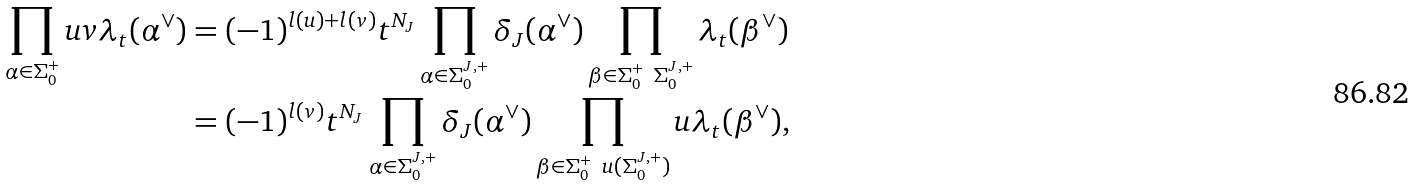<formula> <loc_0><loc_0><loc_500><loc_500>\prod _ { \alpha \in \Sigma _ { 0 } ^ { + } } u v \lambda _ { t } ( \alpha ^ { \vee } ) & = ( - 1 ) ^ { l ( u ) + l ( v ) } t ^ { N _ { J } } \prod _ { \alpha \in \Sigma _ { 0 } ^ { J , + } } \delta _ { J } ( \alpha ^ { \vee } ) \prod _ { \beta \in \Sigma _ { 0 } ^ { + } \ \Sigma _ { 0 } ^ { J , + } } \lambda _ { t } ( \beta ^ { \vee } ) \\ & = ( - 1 ) ^ { l ( v ) } t ^ { N _ { J } } \prod _ { \alpha \in \Sigma _ { 0 } ^ { J , + } } \delta _ { J } ( \alpha ^ { \vee } ) \prod _ { \beta \in \Sigma _ { 0 } ^ { + } \ u ( \Sigma _ { 0 } ^ { J , + } ) } u \lambda _ { t } ( \beta ^ { \vee } ) ,</formula> 